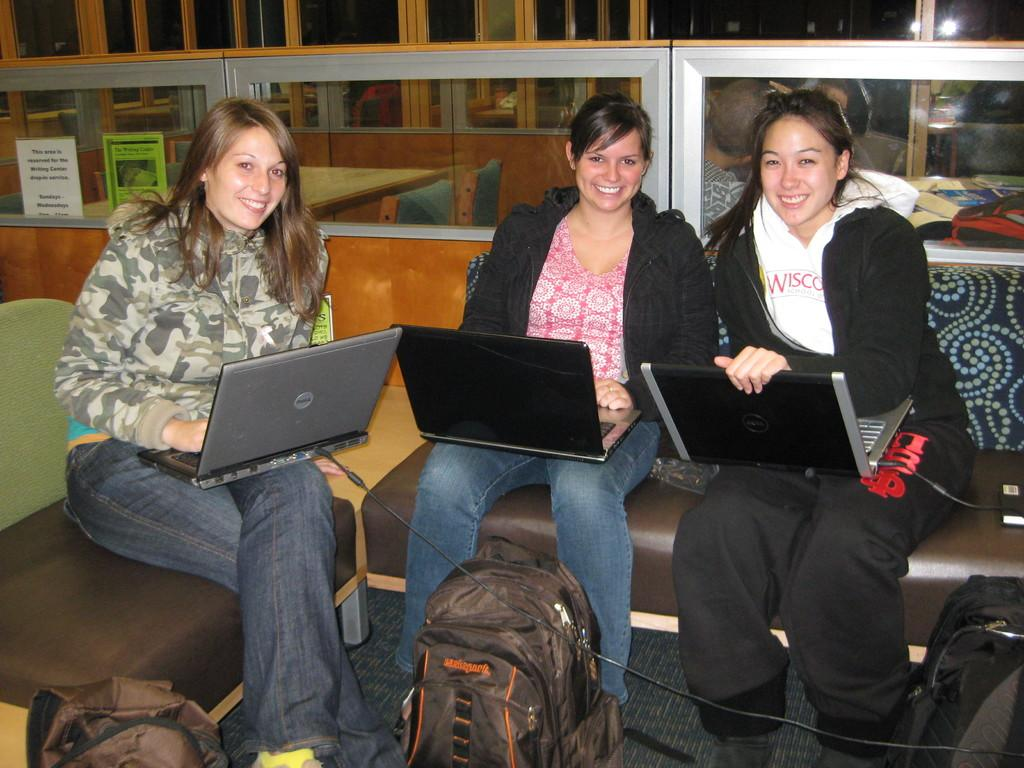How many people are in the image? There are three ladies in the image. What are the ladies doing in the image? The ladies are sitting on a sofa. What objects are the ladies holding? Each lady is holding a laptop. What can be seen in front of the ladies? There are bags in front of the ladies. What is visible in the background of the image? There are cabins with glasses in the background. Are there any mice running around on the sofa in the image? There are no mice visible in the image; the ladies are sitting on the sofa without any mice present. What type of test is being conducted by the ladies in the image? There is no indication of a test being conducted in the image; the ladies are simply sitting on the sofa with laptops. 